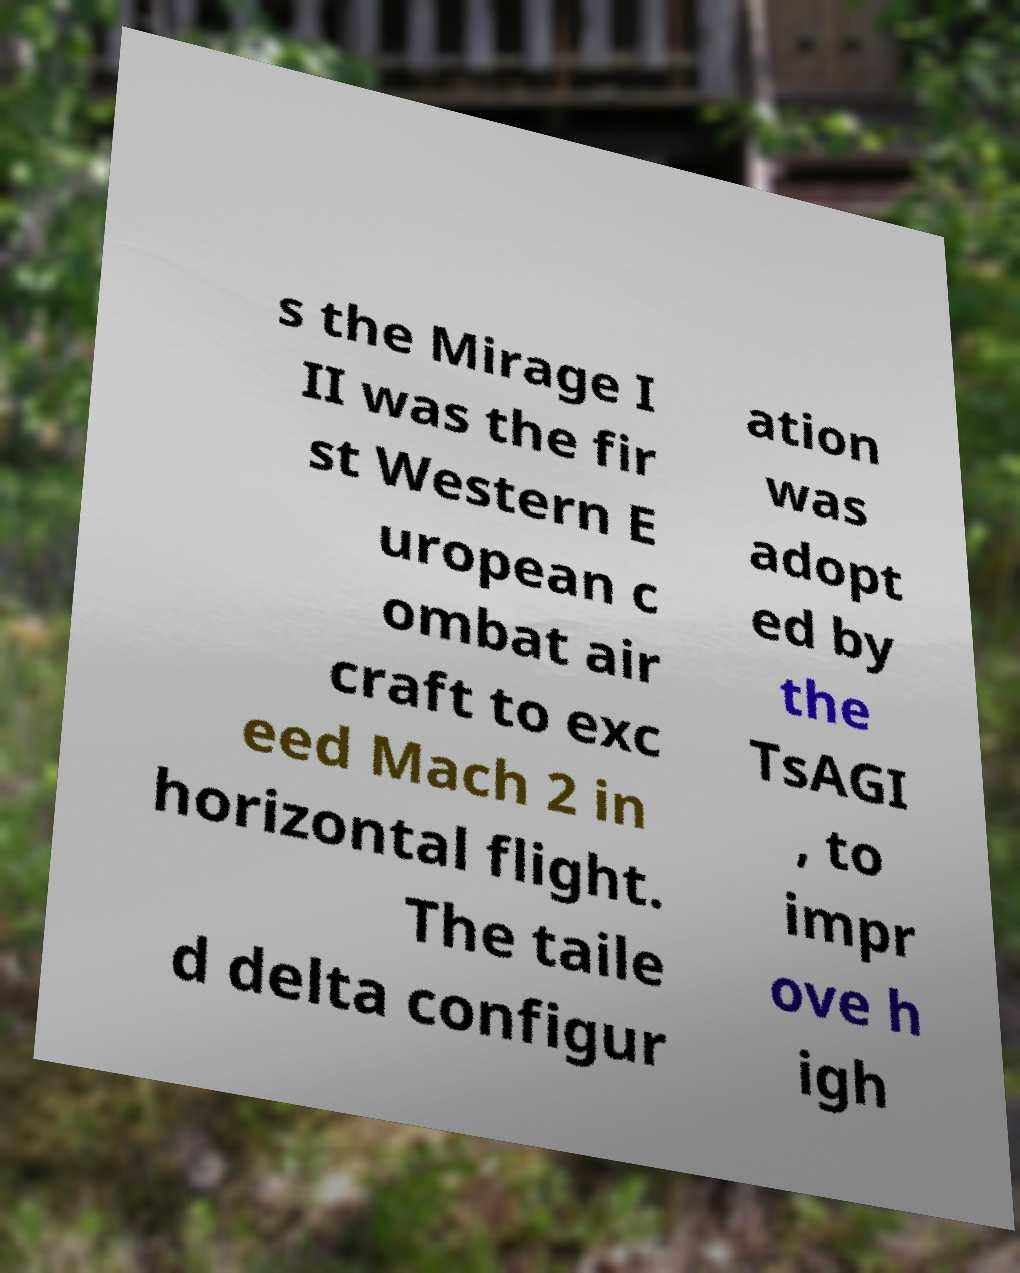What messages or text are displayed in this image? I need them in a readable, typed format. s the Mirage I II was the fir st Western E uropean c ombat air craft to exc eed Mach 2 in horizontal flight. The taile d delta configur ation was adopt ed by the TsAGI , to impr ove h igh 